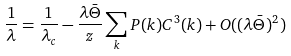<formula> <loc_0><loc_0><loc_500><loc_500>\frac { 1 } { \lambda } = \frac { 1 } { \lambda _ { c } } - \frac { \lambda \bar { \Theta } } { z } \sum _ { k } P ( k ) C ^ { 3 } ( k ) + O ( ( \lambda \bar { \Theta } ) ^ { 2 } )</formula> 